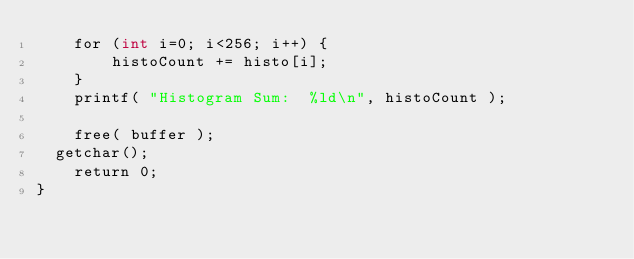<code> <loc_0><loc_0><loc_500><loc_500><_Cuda_>    for (int i=0; i<256; i++) {
        histoCount += histo[i];
    }
    printf( "Histogram Sum:  %ld\n", histoCount );

    free( buffer );
	getchar();
    return 0;
}
</code> 